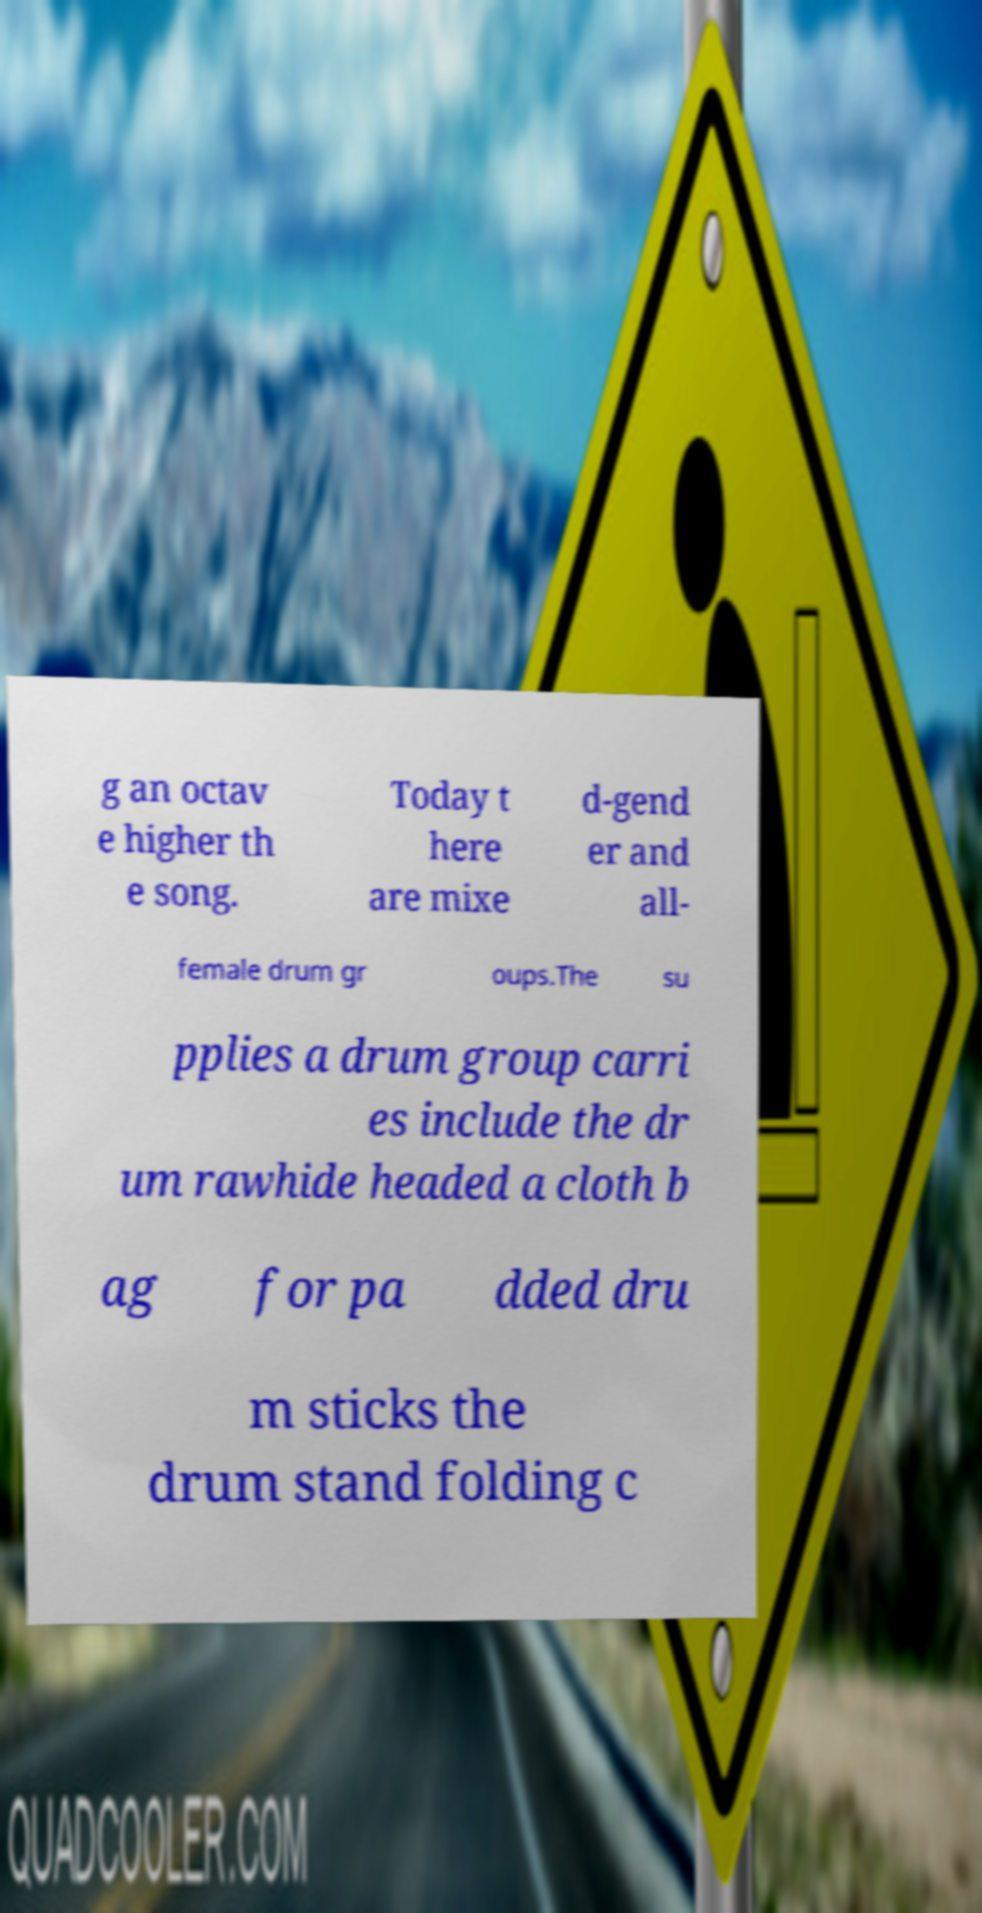Can you accurately transcribe the text from the provided image for me? g an octav e higher th e song. Today t here are mixe d-gend er and all- female drum gr oups.The su pplies a drum group carri es include the dr um rawhide headed a cloth b ag for pa dded dru m sticks the drum stand folding c 